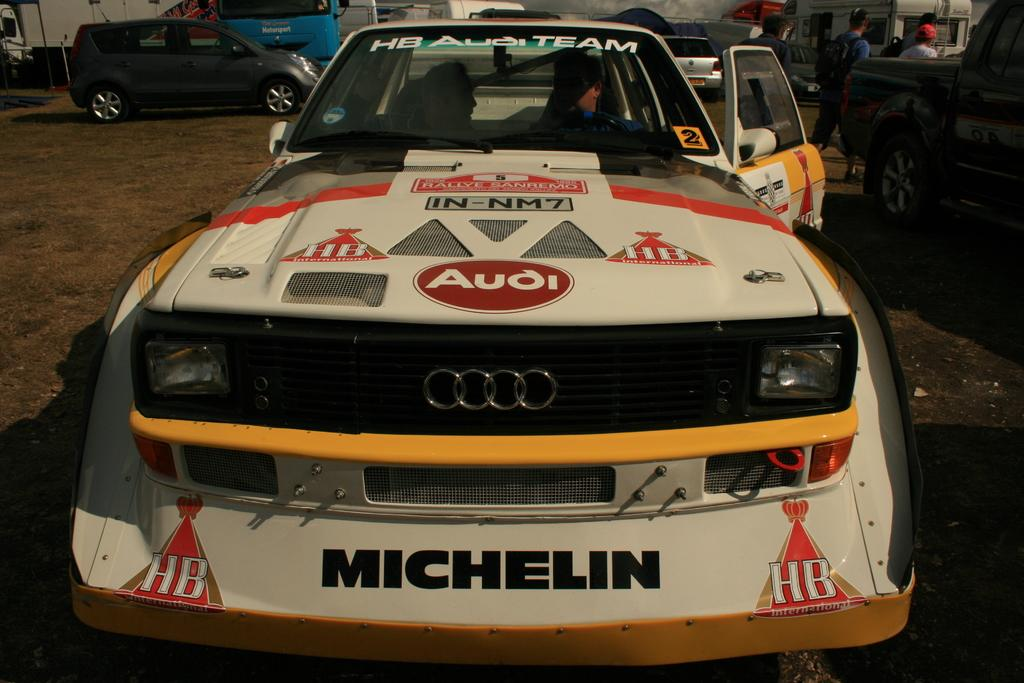<image>
Relay a brief, clear account of the picture shown. The off road race car has many sponsors and one of them is Audi. 